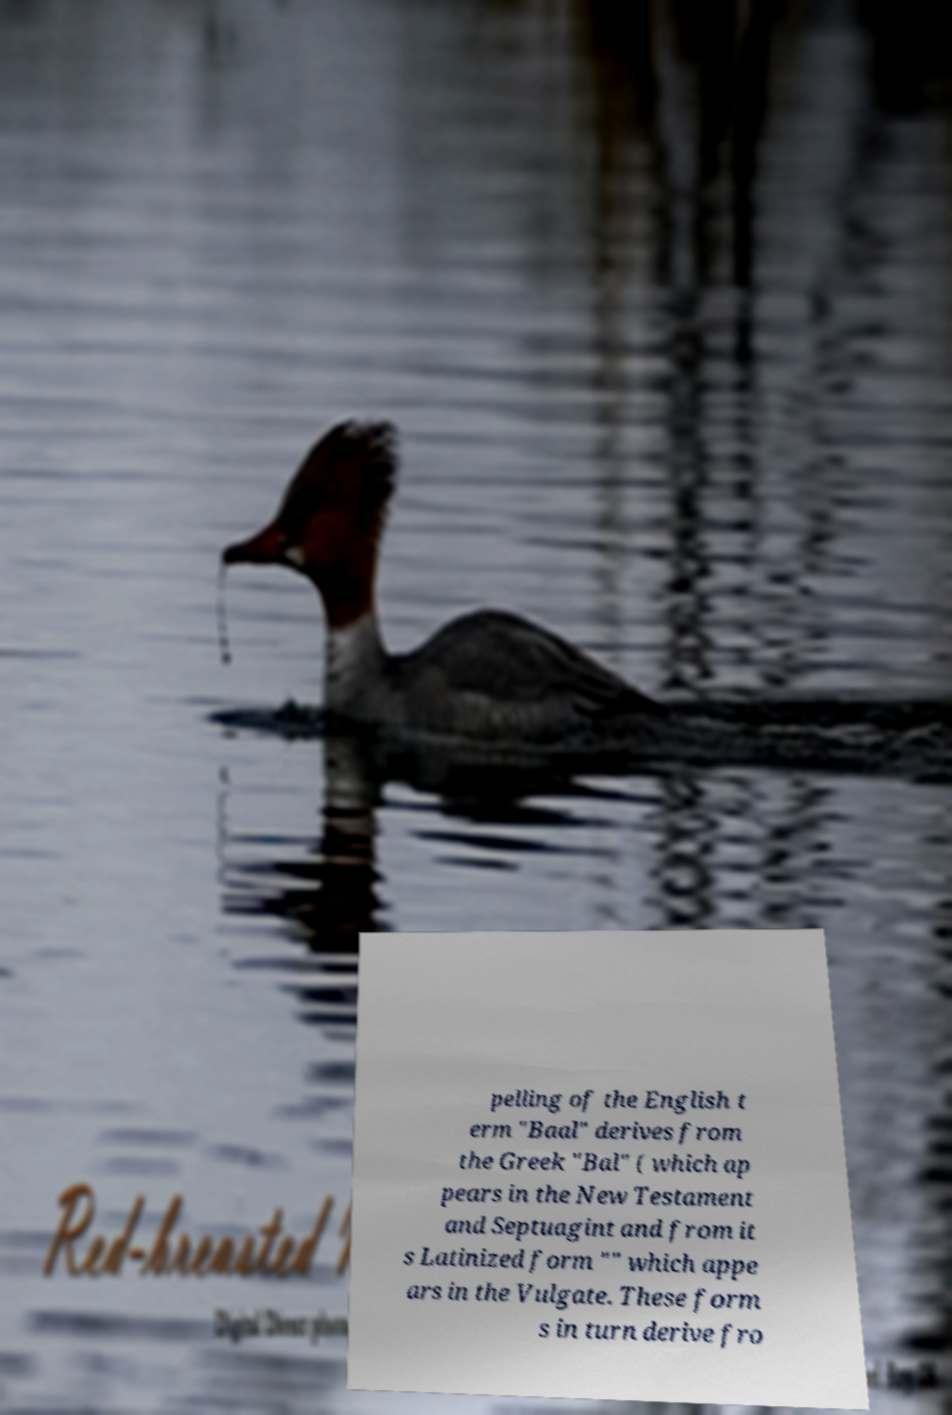Can you read and provide the text displayed in the image?This photo seems to have some interesting text. Can you extract and type it out for me? pelling of the English t erm "Baal" derives from the Greek "Bal" ( which ap pears in the New Testament and Septuagint and from it s Latinized form "" which appe ars in the Vulgate. These form s in turn derive fro 